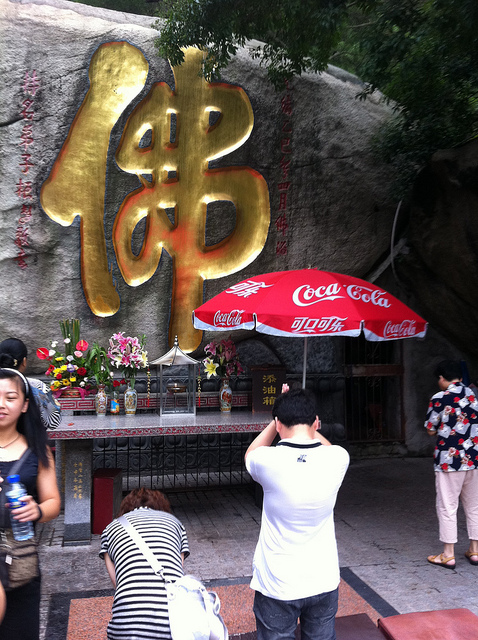<image>Why are these people bowing their heads? It is unknown why these people are bowing their heads. However, the possible reason might be they are praying or worshiping in a holy place. Why are these people bowing their heads? It is not clear why these people are bowing their heads. It can be seen that they are either in a holy place or worshiping. 